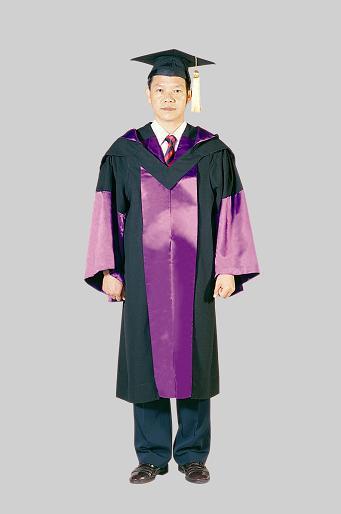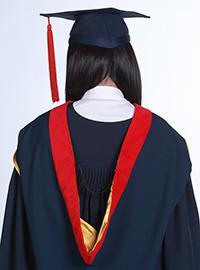The first image is the image on the left, the second image is the image on the right. For the images displayed, is the sentence "The same number of graduates are shown in the left and right images." factually correct? Answer yes or no. Yes. 